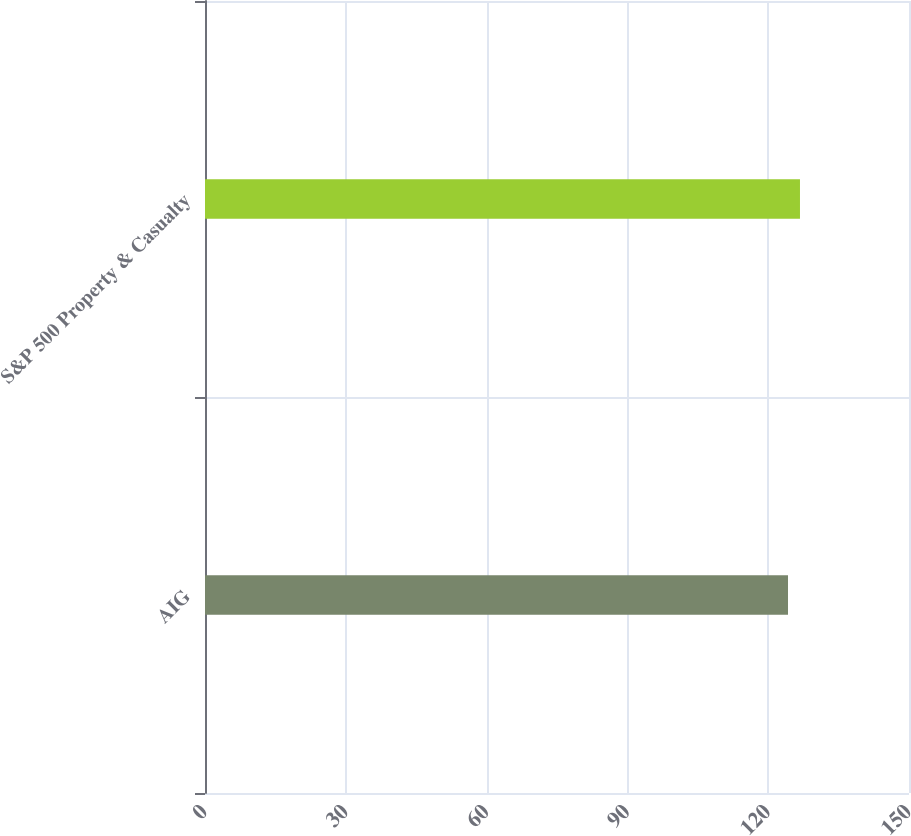<chart> <loc_0><loc_0><loc_500><loc_500><bar_chart><fcel>AIG<fcel>S&P 500 Property & Casualty<nl><fcel>124.22<fcel>126.77<nl></chart> 